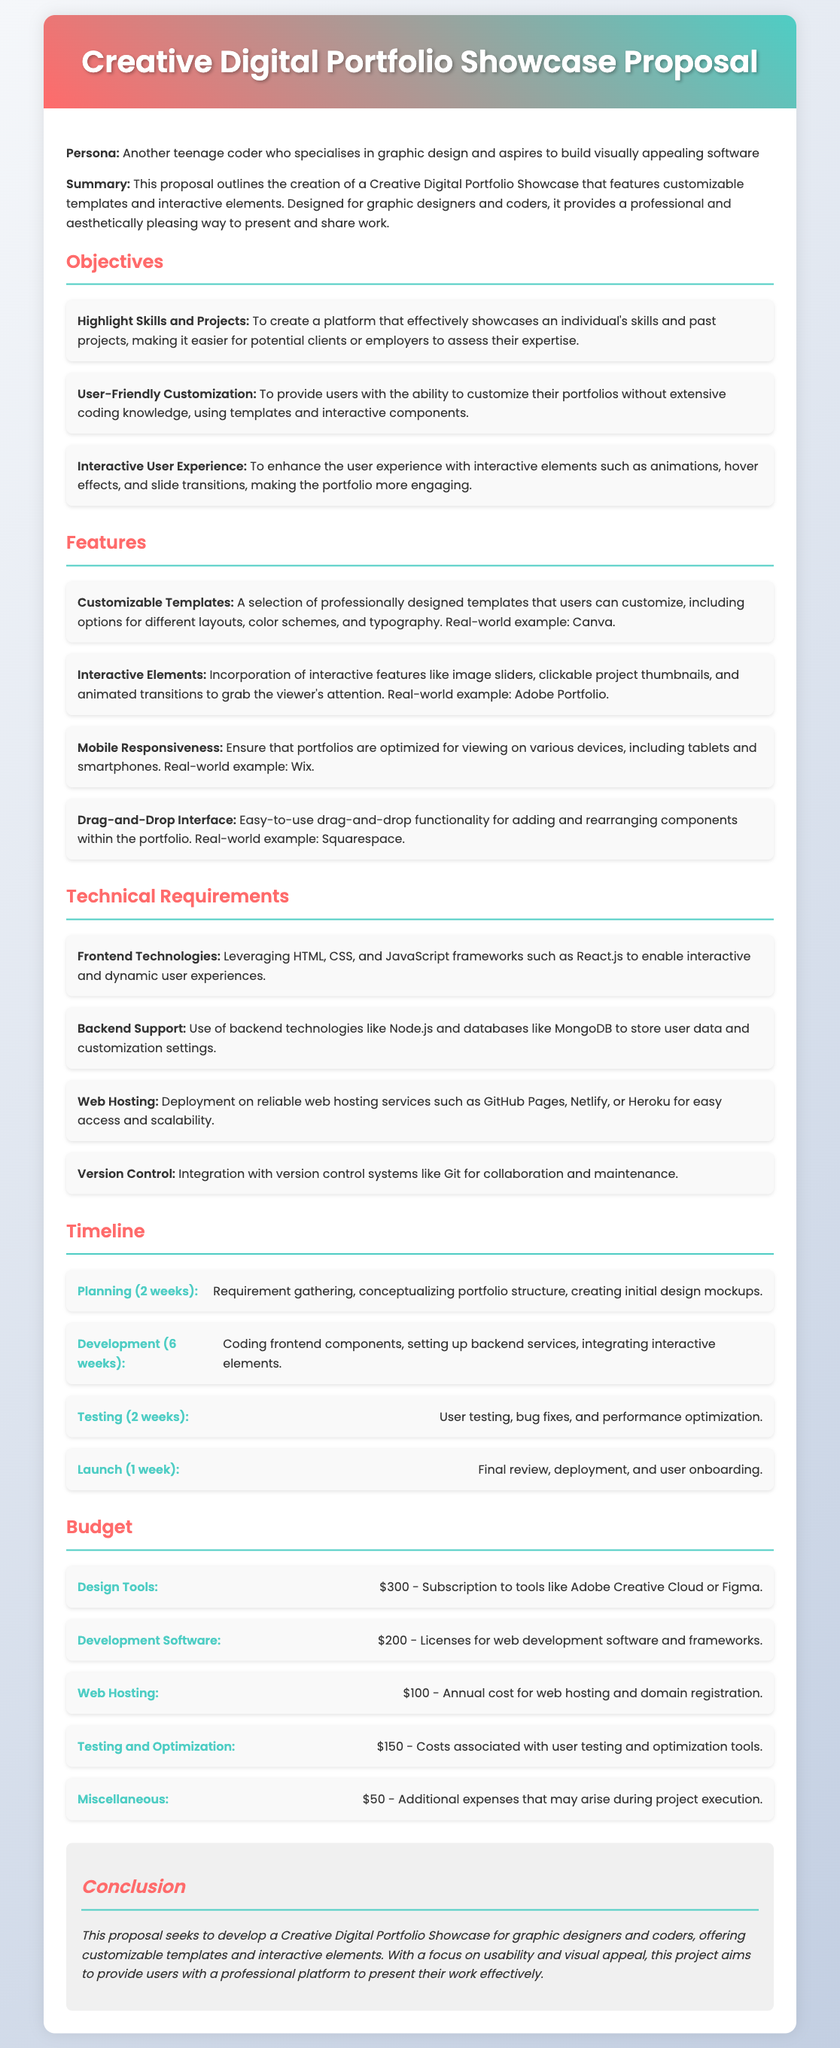What is the title of the proposal? The title of the proposal is stated prominently at the top of the document.
Answer: Creative Digital Portfolio Showcase Proposal How many weeks are allocated for the development phase? The timeline section outlines the duration of each phase, including development.
Answer: 6 weeks What is included in the customizable templates feature? The features section lists what users can customize, providing examples and highlighting characteristics.
Answer: Professionally designed templates What is the total cost for design tools? The budget section provides specific costs associated with various project expenses.
Answer: $300 Which frontend technologies are mentioned? The technical requirements section specifies technologies to be used in the project.
Answer: HTML, CSS, and JavaScript What phase comes after the planning stage? The timeline outlines the sequential order of project phases and their respective durations.
Answer: Development What is the purpose of the project? The introduction summarizes the main objective of the proposal in a concise manner.
Answer: To create a Creative Digital Portfolio Showcase How many different areas are covered in the objectives section? The objectives section lists multiple goals, indicating various aims of the project.
Answer: 3 areas What is the purpose of the conclusion? The conclusion wraps up the proposal by recapping its main focus and intentions.
Answer: To present the project effectively 